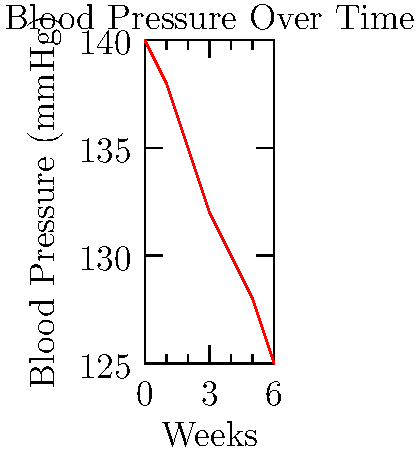Looking at this line graph of blood pressure readings over time, what can you tell me about the overall trend in your blood pressure? To interpret this graph, let's break it down step-by-step:

1. First, look at the axes:
   - The horizontal axis (x-axis) represents time in weeks.
   - The vertical axis (y-axis) shows blood pressure in mmHg (millimeters of mercury).

2. Now, observe the red line on the graph:
   - It starts at the left side of the graph (Week 0) at about 140 mmHg.
   - As you move right (as time progresses), the line moves downward.

3. Compare the beginning and end points:
   - At Week 0, the blood pressure is around 140 mmHg.
   - By Week 6, the blood pressure has decreased to about 125 mmHg.

4. Look at the overall shape of the line:
   - It's moving downward consistently from left to right.
   - There are no sudden spikes or drops; the decrease appears steady.

5. Interpret what this means:
   - A downward slope indicates a decrease in blood pressure over time.
   - The steady nature of the line suggests a consistent improvement.

Given these observations, we can conclude that the overall trend shows a gradual decrease in blood pressure over the 6-week period.
Answer: Decreasing blood pressure over time 